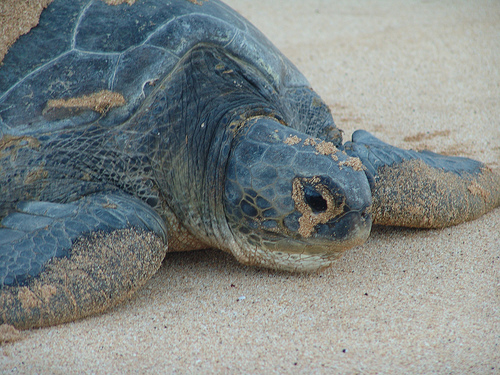<image>
Can you confirm if the turtle is in the sand? Yes. The turtle is contained within or inside the sand, showing a containment relationship. 